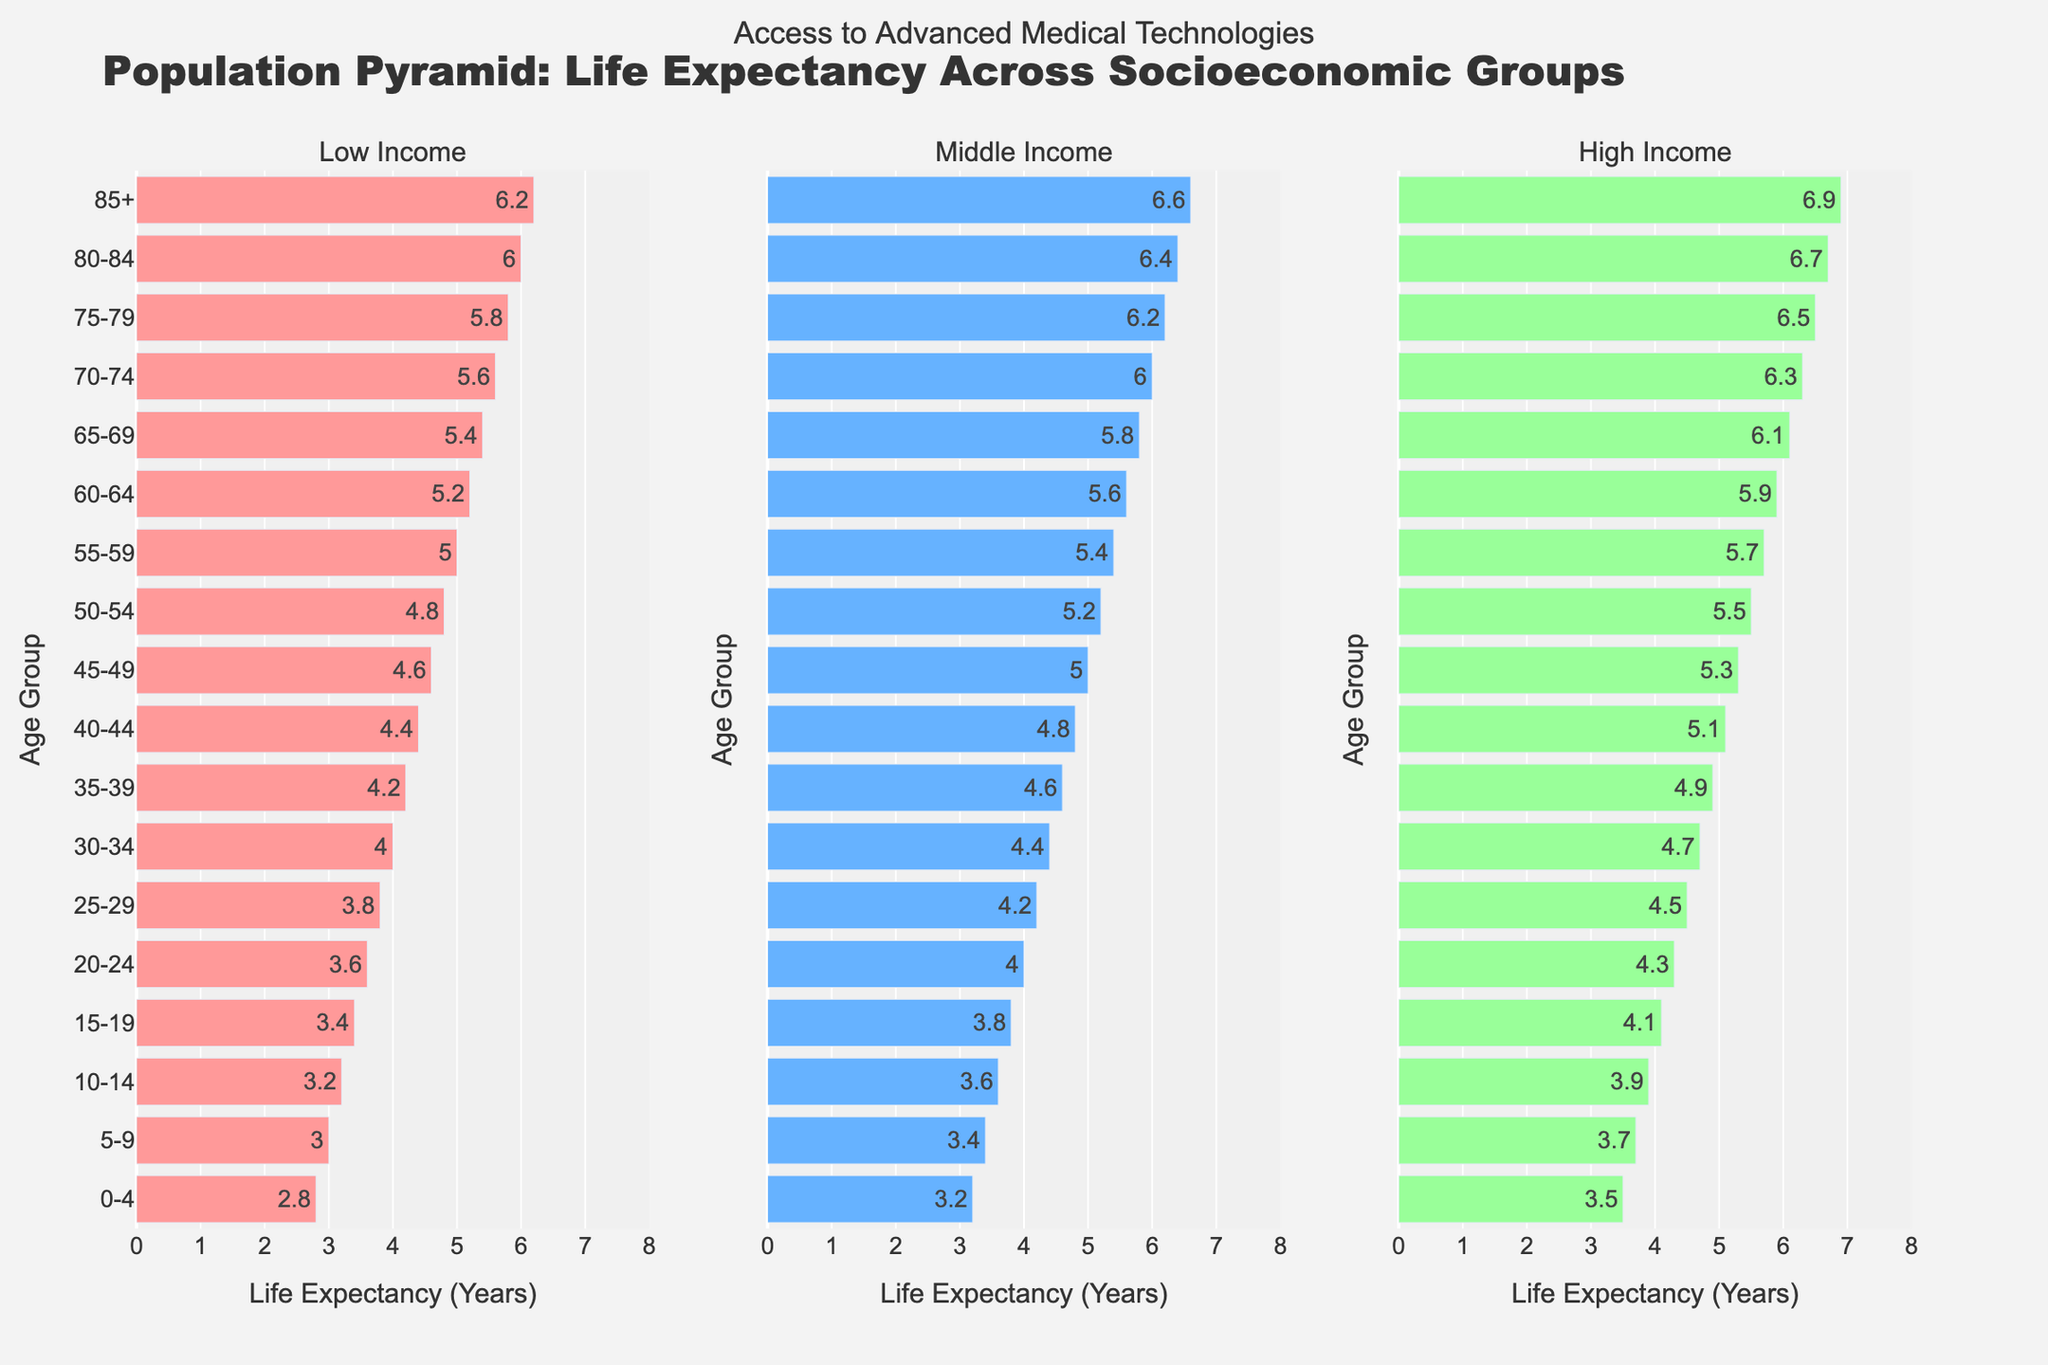What is the title of the plot? The title of the plot appears at the top of the figure and reads "Population Pyramid: Life Expectancy Across Socioeconomic Groups".
Answer: Population Pyramid: Life Expectancy Across Socioeconomic Groups Which age group has the highest life expectancy in the High-Income section? Looking at the High-Income column, the age group “85+” has the highest value of 6.9.
Answer: 85+ What is the life expectancy for the age group 0-4 in the Low-Income group? In the Low-Income column, for the age group 0-4, the life expectancy is 2.8.
Answer: 2.8 Which socioeconomic group shows the highest life expectancy for the age group 45-49? Compare the values for the age group 45-49 across all three columns. The High-Income group has a value of 5.3, which is the highest.
Answer: High Income How does the life expectancy for the age group 30-34 compare between Middle-Income and Low-Income groups? In the age group 30-34, the Middle-Income group has a value of 4.4, while the Low-Income group has a value of 4.0. Thus, Middle-Income has a higher value by 0.4.
Answer: Middle-Income is higher by 0.4 What is the average life expectancy for the age group 60-64 across all socioeconomic groups? Add the life expectancy values for 60-64 across all groups: 5.2 (Low) + 5.6 (Middle) + 5.9 (High) = 16.7. Divide by 3 to get the average: 16.7/3 = 5.57.
Answer: 5.57 For which age group is the difference in life expectancy between the High-Income and Low-Income groups the greatest? Calculate the differences for each age group. The 85+ group has the greatest difference: 6.9 (High) - 6.2 (Low) = 0.7.
Answer: 85+ Which group has a consistent increasing trend in life expectancy across all age groups? Examine the trend line for each group across all age groups. The High-Income group shows a consistent increase in life expectancy as age increases.
Answer: High Income Which age group has the lowest life expectancy in the Middle-Income section? In the Middle-Income column, the age group with the lowest value is 0-4, with a life expectancy of 3.2.
Answer: 0-4 